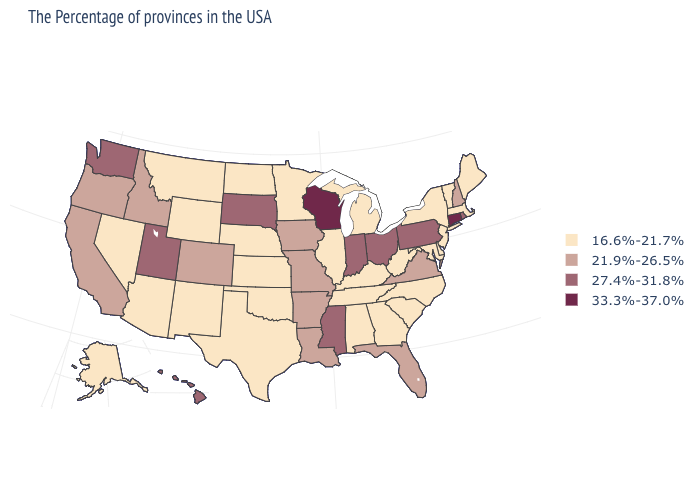Is the legend a continuous bar?
Give a very brief answer. No. What is the value of New Mexico?
Quick response, please. 16.6%-21.7%. What is the value of Connecticut?
Be succinct. 33.3%-37.0%. Does Utah have the lowest value in the USA?
Write a very short answer. No. Among the states that border Maine , which have the lowest value?
Write a very short answer. New Hampshire. Does Ohio have the lowest value in the MidWest?
Short answer required. No. What is the value of Massachusetts?
Quick response, please. 16.6%-21.7%. Which states have the lowest value in the USA?
Concise answer only. Maine, Massachusetts, Vermont, New York, New Jersey, Delaware, Maryland, North Carolina, South Carolina, West Virginia, Georgia, Michigan, Kentucky, Alabama, Tennessee, Illinois, Minnesota, Kansas, Nebraska, Oklahoma, Texas, North Dakota, Wyoming, New Mexico, Montana, Arizona, Nevada, Alaska. Name the states that have a value in the range 27.4%-31.8%?
Be succinct. Rhode Island, Pennsylvania, Ohio, Indiana, Mississippi, South Dakota, Utah, Washington, Hawaii. Does Arizona have the highest value in the USA?
Quick response, please. No. What is the value of Minnesota?
Write a very short answer. 16.6%-21.7%. Does Virginia have the lowest value in the USA?
Quick response, please. No. Does South Carolina have the highest value in the South?
Give a very brief answer. No. Does Idaho have a lower value than Pennsylvania?
Write a very short answer. Yes. What is the value of California?
Write a very short answer. 21.9%-26.5%. 